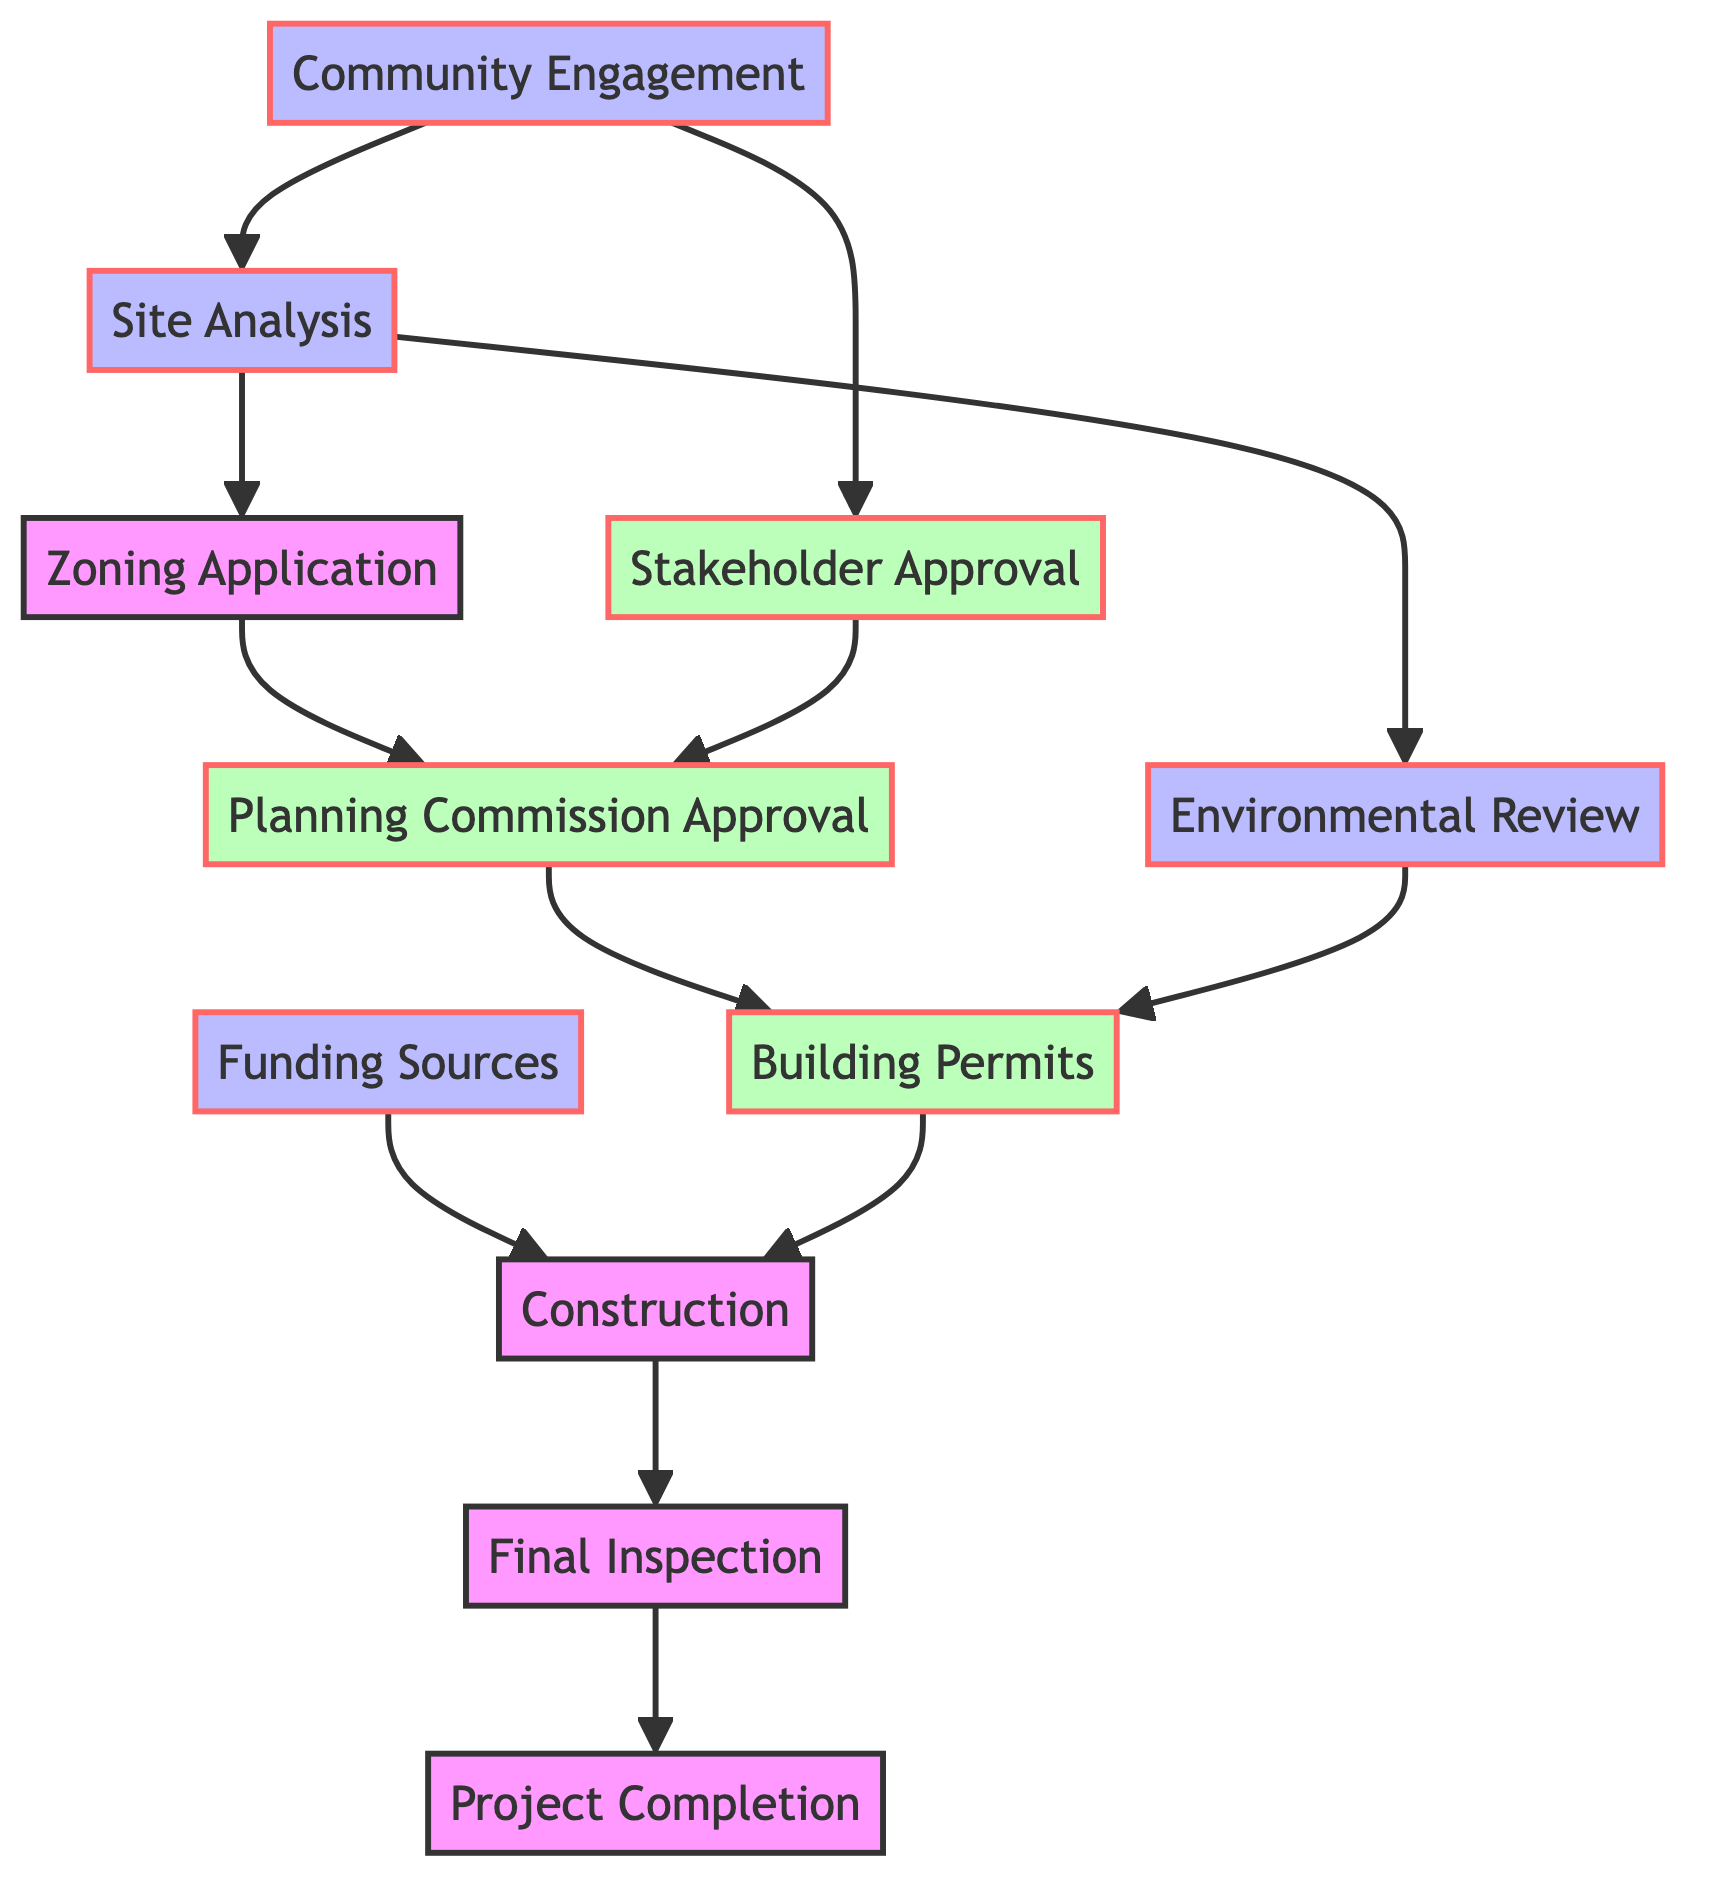What is the first step in the real estate development process? The diagram shows that the first step in the real estate development process is "Community Engagement," which involves initial discussions with community members.
Answer: Community Engagement How many nodes are there in this diagram? By counting the distinct elements listed in the diagram, there are a total of 11 nodes representing different stages in the real estate development process.
Answer: 11 Which step follows "Zoning Application"? According to the diagram, the step that follows "Zoning Application" is "Planning Commission Approval," indicating the need for approval before moving forward.
Answer: Planning Commission Approval What are the two routes that lead to "Building Permits"? The diagram indicates two routes to "Building Permits": from "Planning Commission Approval" and from "Environmental Review," showcasing different paths that can be taken to obtain these permits.
Answer: Planning Commission Approval, Environmental Review How does "Community Engagement" relate to "Stakeholder Approval"? The diagram shows that "Community Engagement" directly leads to "Stakeholder Approval," implying that engaging with the community is vital for gaining approval from local stakeholders.
Answer: Directly leads to What is the final step in the development process? The final step illustrated in the diagram is "Project Completion," which signifies the end of the process and readiness for occupancy.
Answer: Project Completion Which steps require approvals? The diagram identifies three points that require approvals: "Planning Commission Approval," "Stakeholder Approval," and "Building Permits," highlighting essential checkpoints in the development process.
Answer: Planning Commission Approval, Stakeholder Approval, Building Permits What is the relationship between "Construction" and "Final Inspection"? The diagram indicates that "Construction" directly leads to "Final Inspection," meaning that the construction phase must be completed before a final inspection can be conducted.
Answer: Directly leads to How many distinct approvals are needed in the process? The diagram shows that three distinct approvals are needed: "Planning Commission Approval," "Stakeholder Approval," and "Building Permits," which are critical to the development process.
Answer: 3 